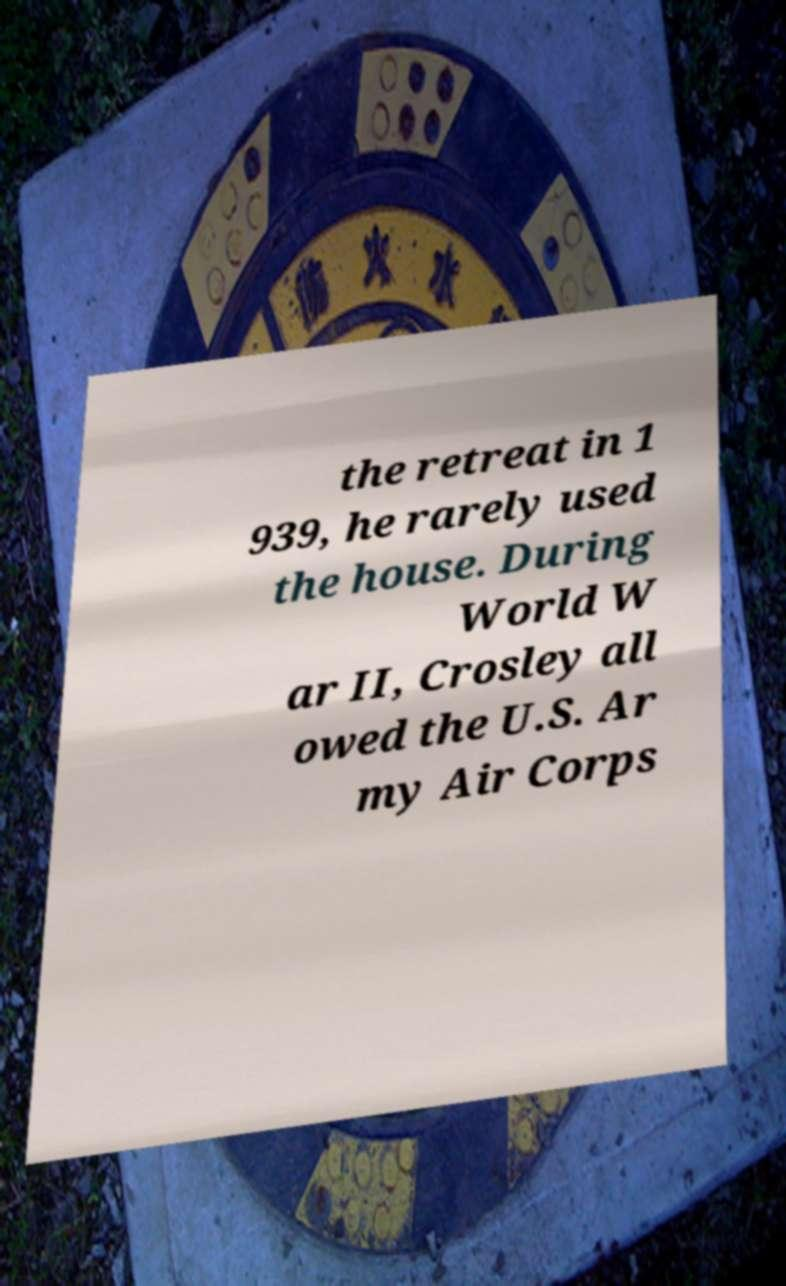For documentation purposes, I need the text within this image transcribed. Could you provide that? the retreat in 1 939, he rarely used the house. During World W ar II, Crosley all owed the U.S. Ar my Air Corps 